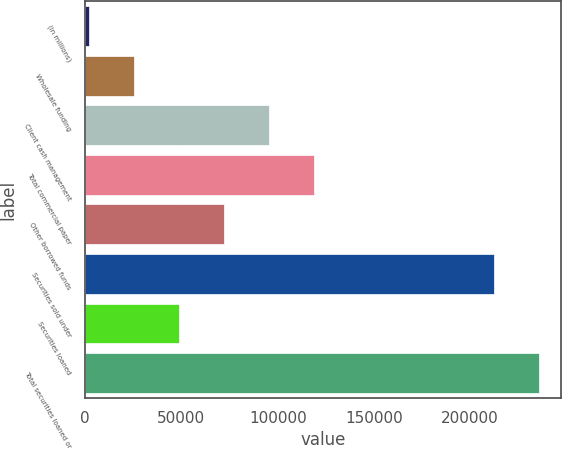Convert chart to OTSL. <chart><loc_0><loc_0><loc_500><loc_500><bar_chart><fcel>(in millions)<fcel>Wholesale funding<fcel>Client cash management<fcel>Total commercial paper<fcel>Other borrowed funds<fcel>Securities sold under<fcel>Securities loaned<fcel>Total securities loaned or<nl><fcel>2012<fcel>25351.1<fcel>95368.4<fcel>118708<fcel>72029.3<fcel>212278<fcel>48690.2<fcel>235617<nl></chart> 